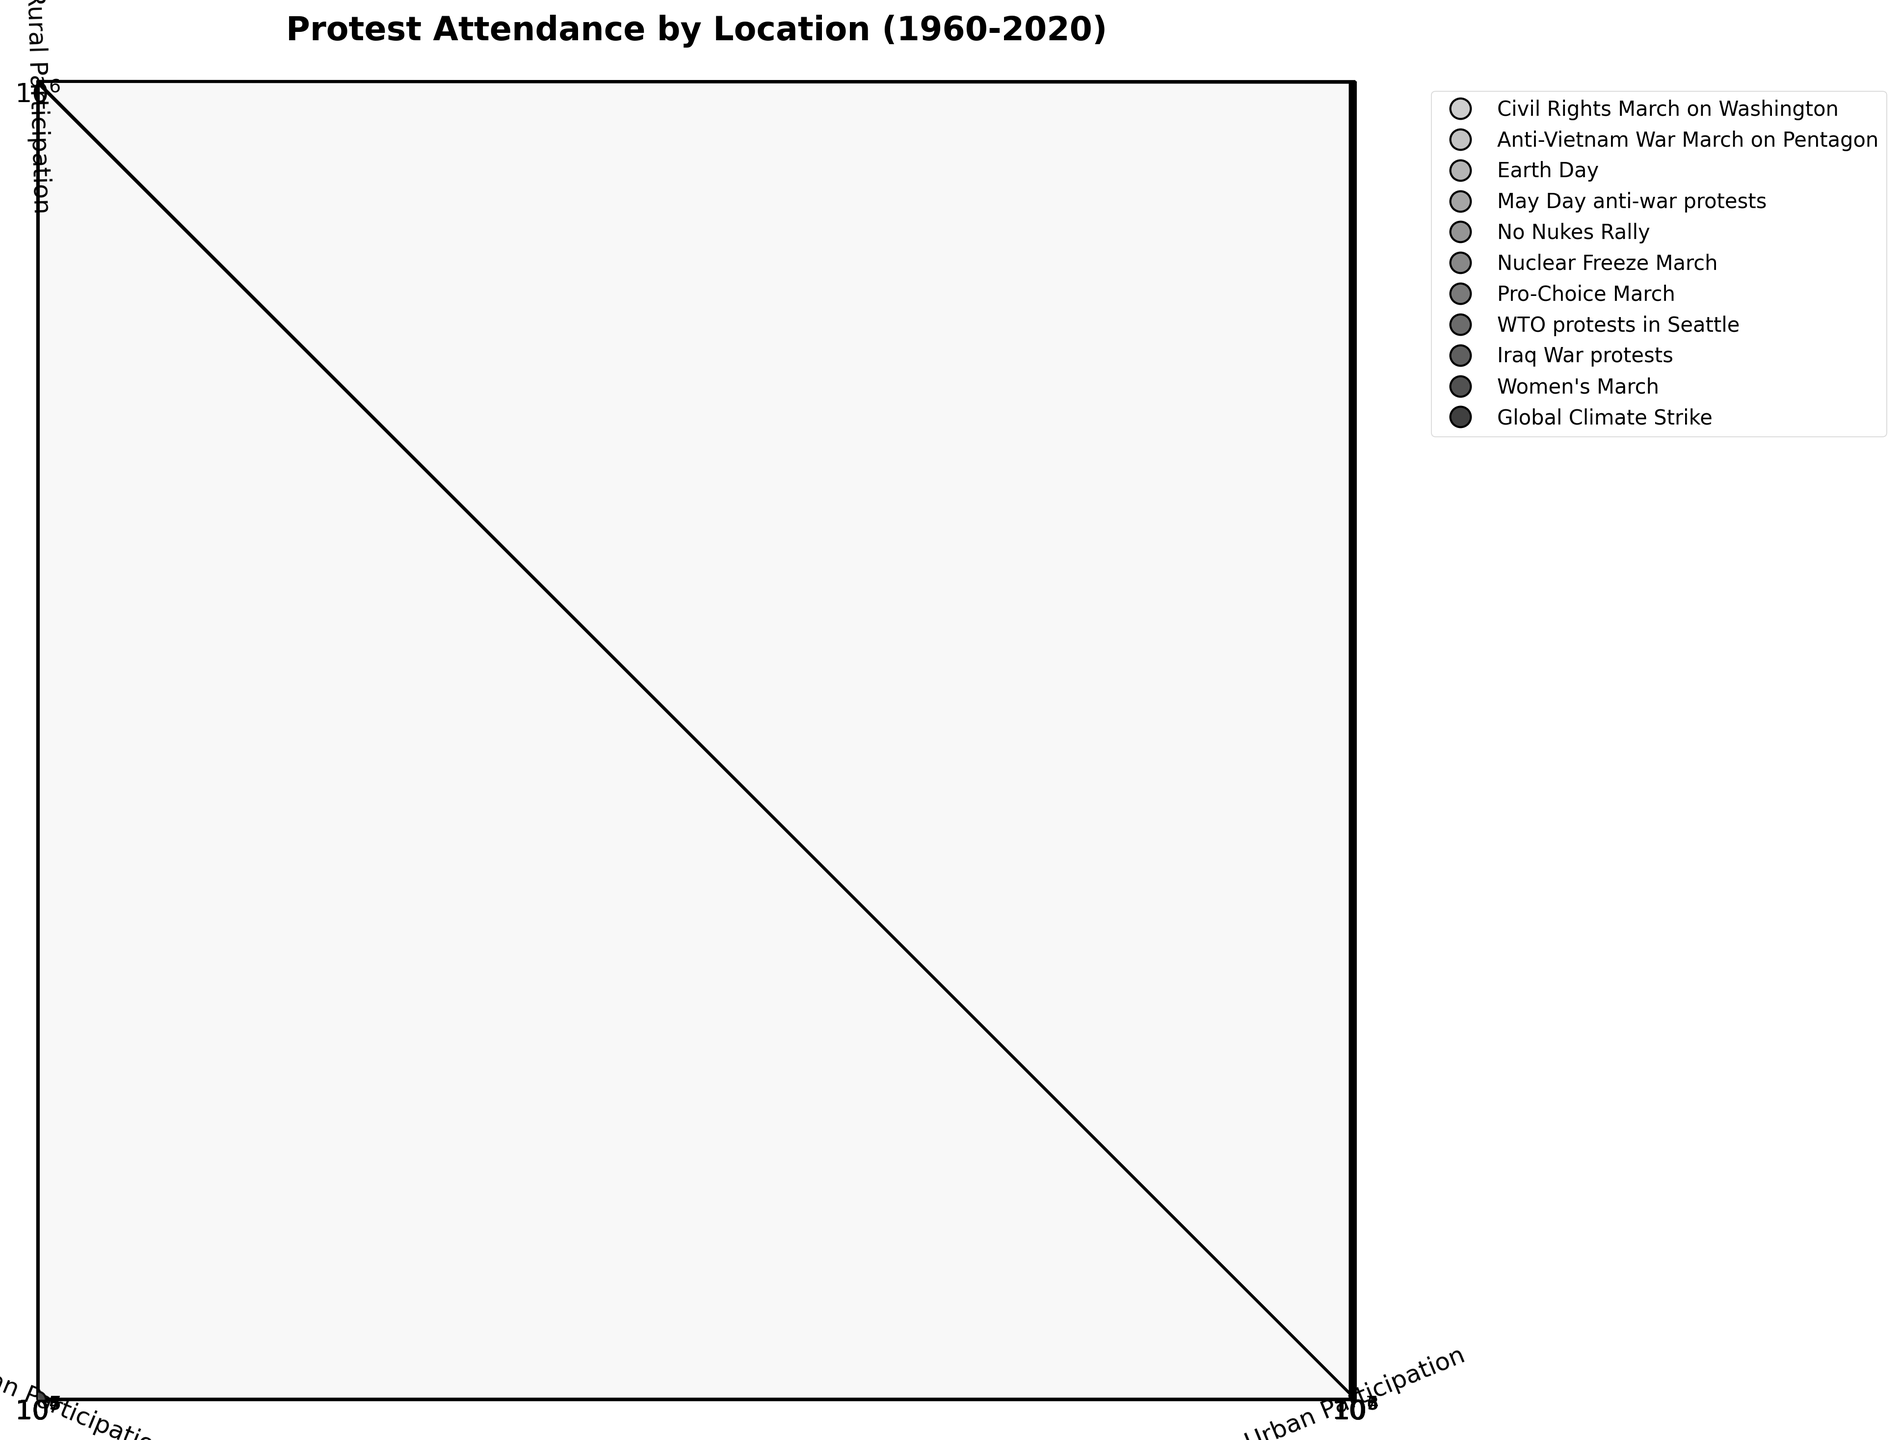What is the title of the plot? The title of the plot appears at the top of the figure. It reads "Protest Attendance by Location (1960-2020)"
Answer: Protest Attendance by Location (1960-2020) Which axis represents urban participation? The axis labels indicate the representation of data points. The axis with the label 'Urban Participation' represents urban participation.
Answer: X-axis How many movements are represented in the plot? Each unique color-coded legend element represents a different movement. Counting these elements gives the number of movements.
Answer: 11 Which protest had the highest urban participation, and what was the approximate number? Identify the data point on the X-axis (urban participation) with the highest value and reference the movement and figure.
Answer: Women's March, 3,500,000 In which location was the participation of the No Nukes Rally the highest? Compare the values for urban, suburban, and rural participation for the No Nukes Rally. The highest value indicates the location with the most participation.
Answer: Urban What is the range of suburban participation values displayed in the plot? Identify the smallest and largest values on the Y-axis (suburban participation) among all data points. Calculate the range by subtracting the smallest value from the largest value.
Answer: 1,000 to 1,000,000 Between the Civil Rights March on Washington and the Women's March, which protest had a higher rural participation, and by how much? Look at the Z-axis (rural participation) values for both protests. Subtract the value for the Civil Rights March on Washington from the Women's March value.
Answer: Women's March, by 240,000 Calculate the average urban participation across all protests represented. Sum the urban participation values for all protests and divide by the number of protests. Add all urban values: 185,000 + 75,000 + 750,000 + 45,000 + 150,000 + 600,000 + 300,000 + 40,000 + 400,000 + 3,500,000 + 1,200,000 = 7,245,000. Divide by 11 (number of protests).
Answer: 658,636 Which movement had the largest disparity between urban and rural participation? Calculate the difference between urban and rural participation for each movement and identify the largest difference. Examples: Women's March (3,500,000 - 250,000), Global Climate Strike (1,200,000 - 100,000), Earth Day (750,000 - 50,000), and others.
Answer: Women's March What does a larger marker size indicate in this plot? Marker size corresponds to the difference in years since 1960. Larger markers indicate more recent protests.
Answer: More recent protests 